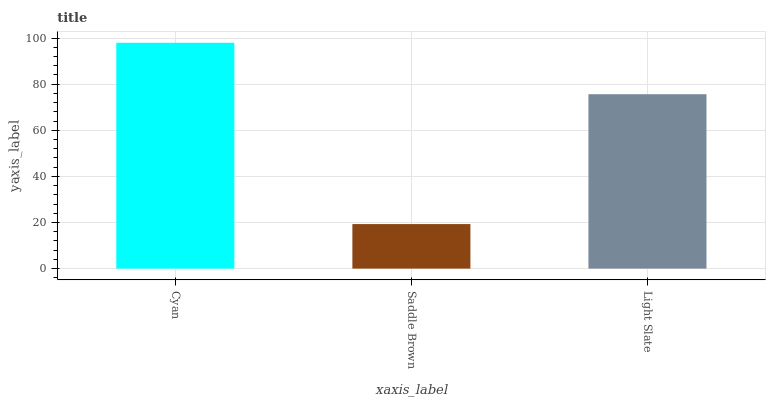Is Saddle Brown the minimum?
Answer yes or no. Yes. Is Cyan the maximum?
Answer yes or no. Yes. Is Light Slate the minimum?
Answer yes or no. No. Is Light Slate the maximum?
Answer yes or no. No. Is Light Slate greater than Saddle Brown?
Answer yes or no. Yes. Is Saddle Brown less than Light Slate?
Answer yes or no. Yes. Is Saddle Brown greater than Light Slate?
Answer yes or no. No. Is Light Slate less than Saddle Brown?
Answer yes or no. No. Is Light Slate the high median?
Answer yes or no. Yes. Is Light Slate the low median?
Answer yes or no. Yes. Is Saddle Brown the high median?
Answer yes or no. No. Is Saddle Brown the low median?
Answer yes or no. No. 